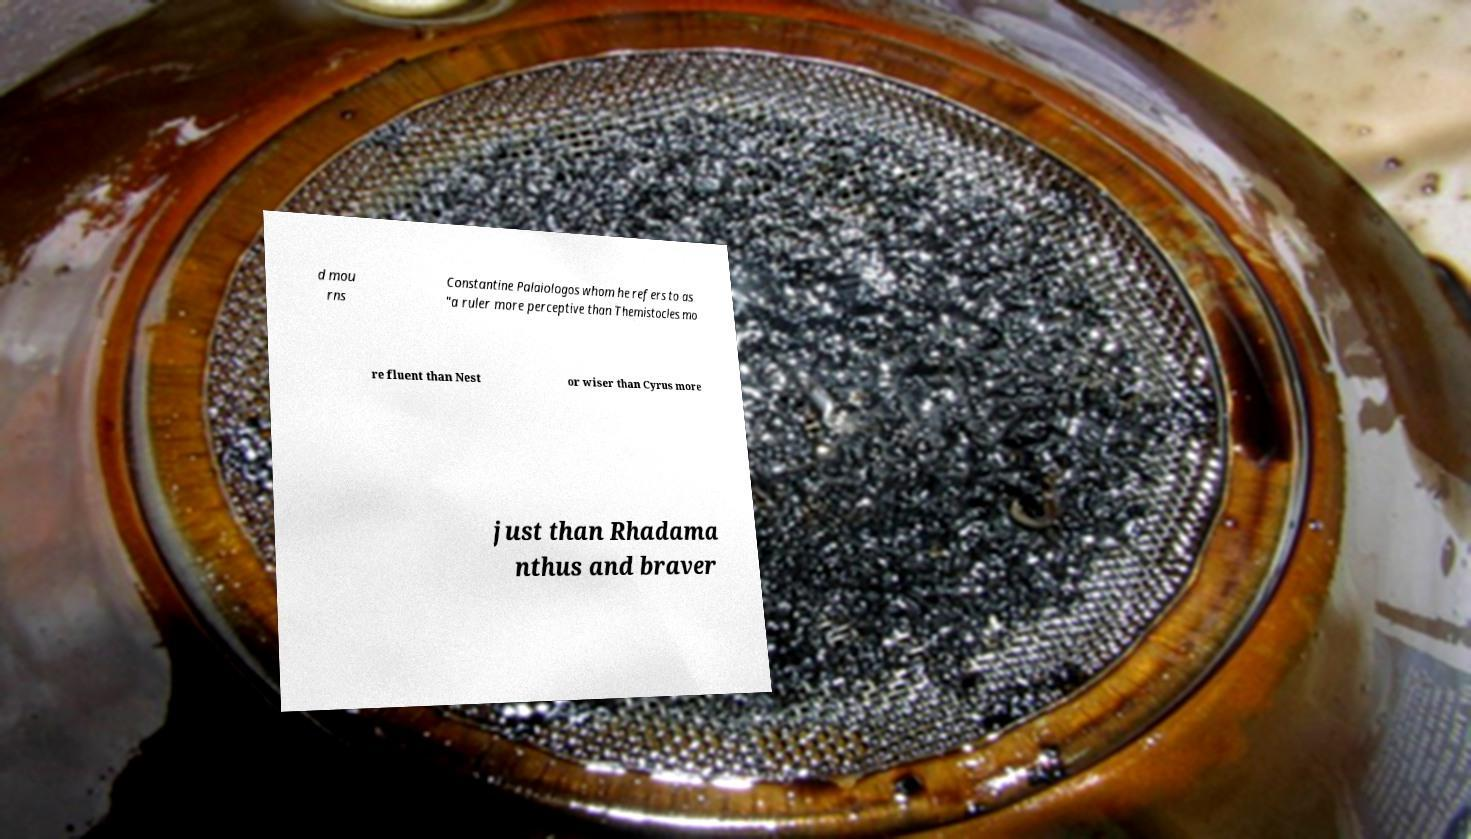Please identify and transcribe the text found in this image. d mou rns Constantine Palaiologos whom he refers to as "a ruler more perceptive than Themistocles mo re fluent than Nest or wiser than Cyrus more just than Rhadama nthus and braver 